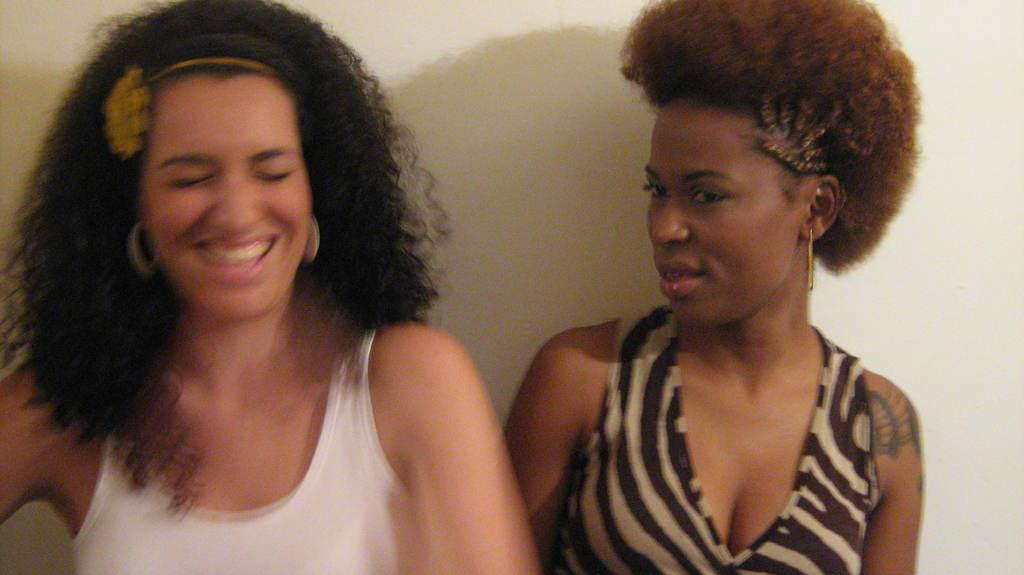How many women are in the image? There are two women in the image. What is the facial expression of the woman on the left side? The woman on the left side is smiling. What color is the wall in the background of the image? The wall in the background of the image is white. What type of music can be heard in the background of the image? There is no music present in the image, as it is a still photograph. 